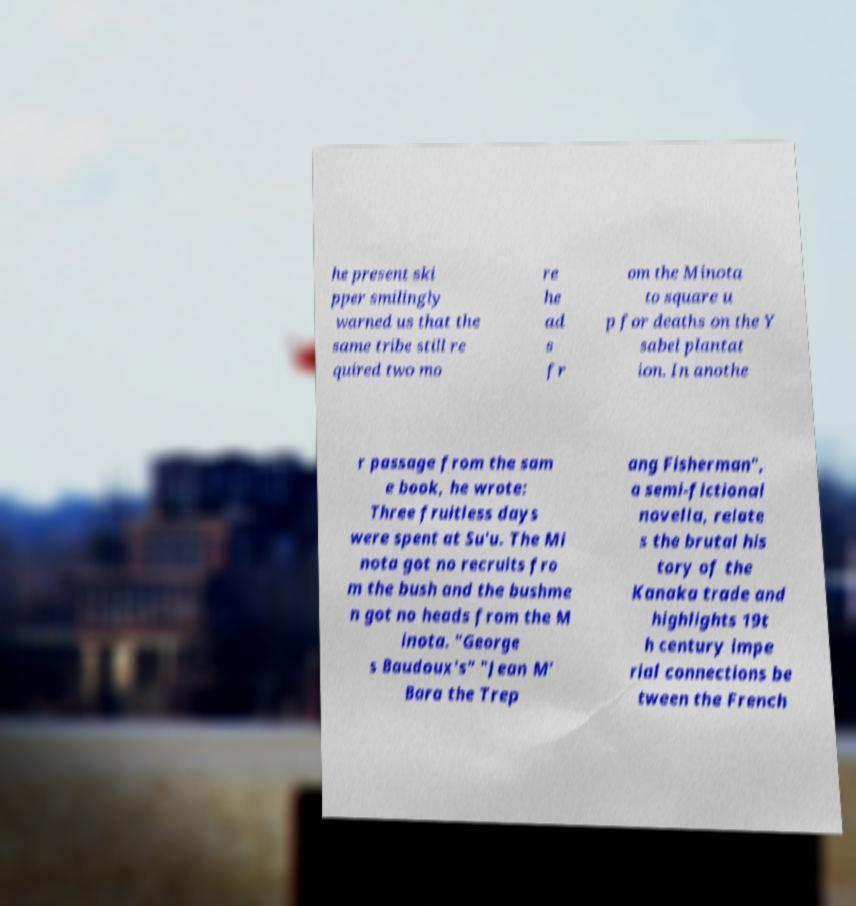I need the written content from this picture converted into text. Can you do that? he present ski pper smilingly warned us that the same tribe still re quired two mo re he ad s fr om the Minota to square u p for deaths on the Y sabel plantat ion. In anothe r passage from the sam e book, he wrote: Three fruitless days were spent at Su'u. The Mi nota got no recruits fro m the bush and the bushme n got no heads from the M inota. "George s Baudoux's" "Jean M’ Bara the Trep ang Fisherman", a semi-fictional novella, relate s the brutal his tory of the Kanaka trade and highlights 19t h century impe rial connections be tween the French 